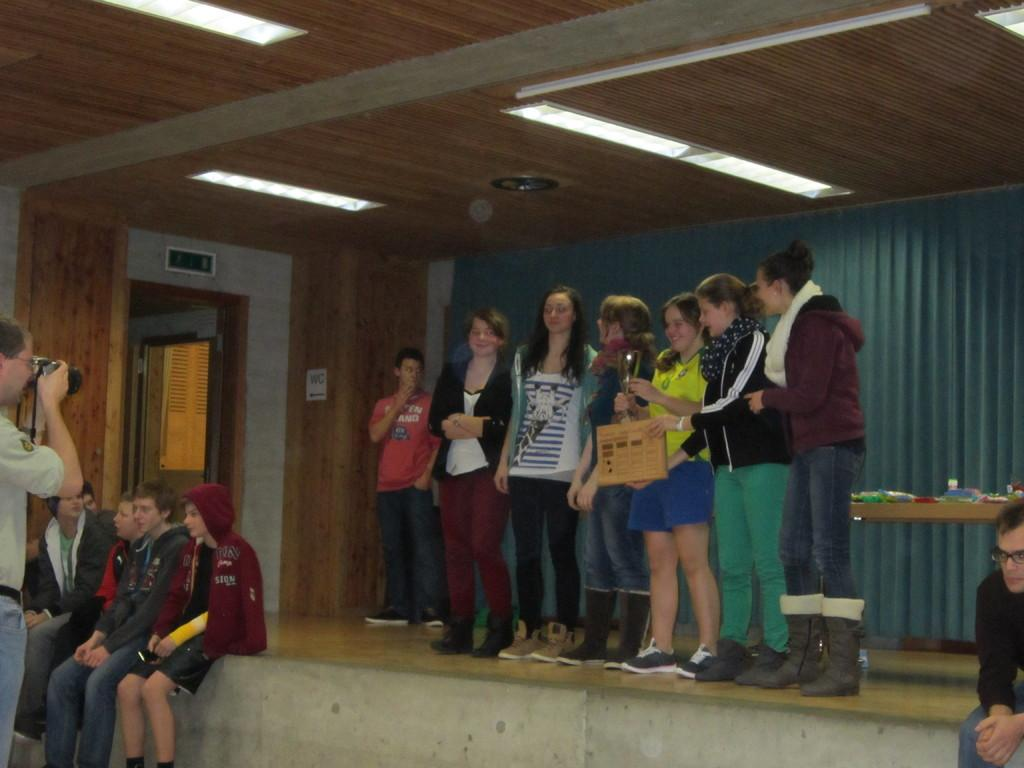How many people are in the image? There are people in the image, but the exact number is not specified. What can be seen in the image besides people? There are lights, a door, a curtain, a table, and a wall in the image. What is the woman holding in the image? The woman is holding a trophy in the image. What is the person on the left side of the image doing? The person on the left side of the image is holding a camera. What type of protest is taking place in the image? There is no protest present in the image. Can you see any birds in the image? There are no birds visible in the image. 